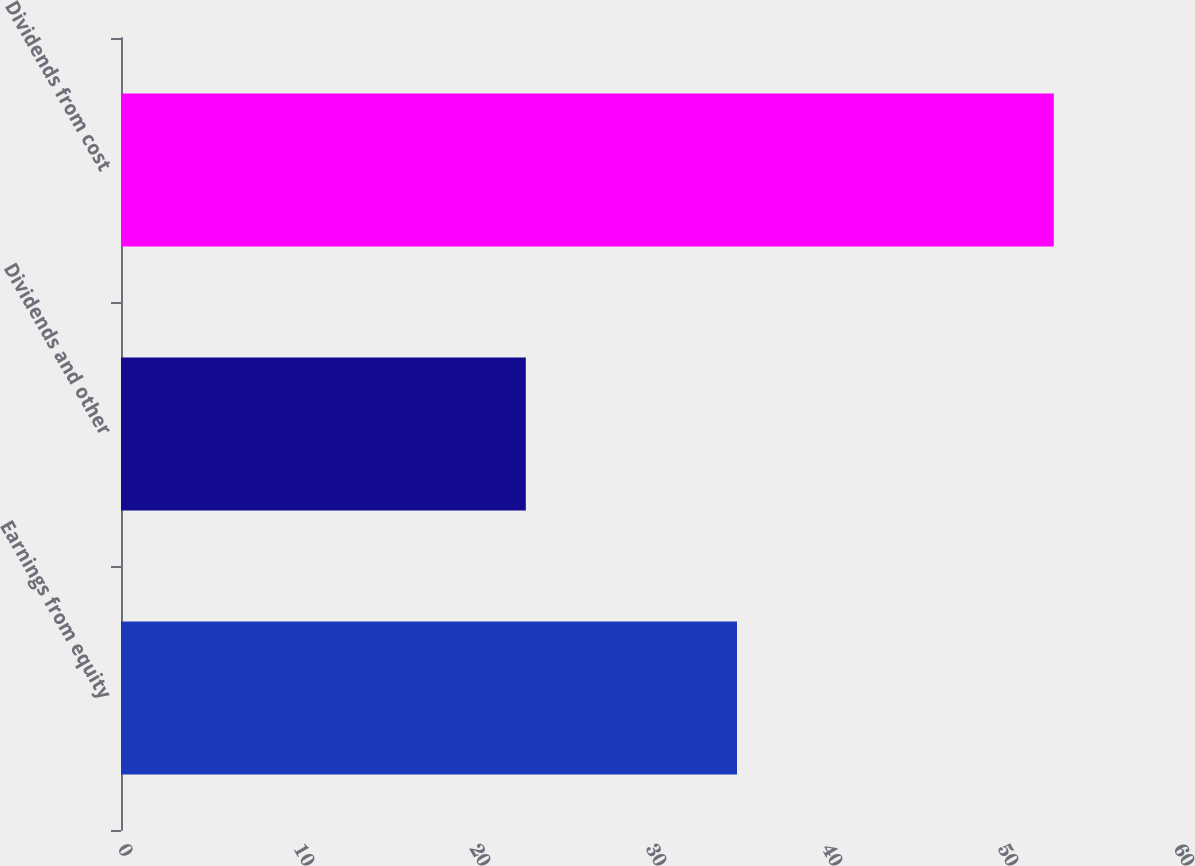Convert chart. <chart><loc_0><loc_0><loc_500><loc_500><bar_chart><fcel>Earnings from equity<fcel>Dividends and other<fcel>Dividends from cost<nl><fcel>35<fcel>23<fcel>53<nl></chart> 